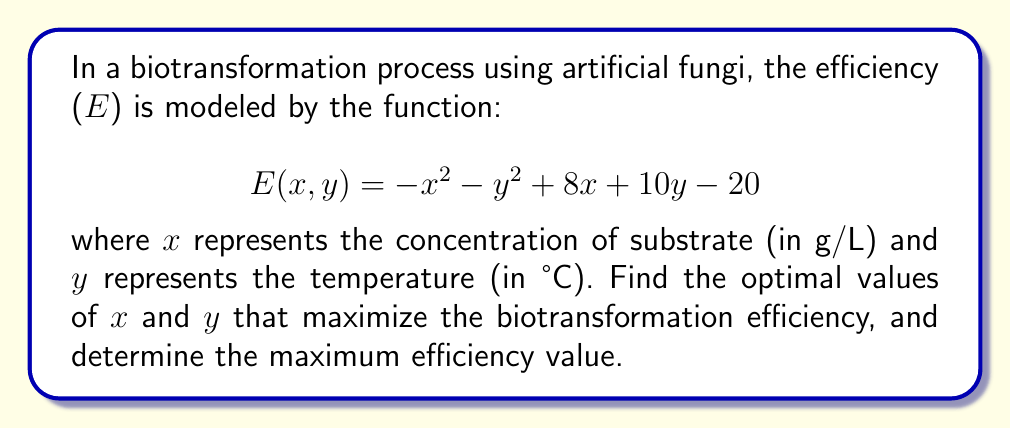Give your solution to this math problem. To find the optimal values of x and y that maximize the biotransformation efficiency, we need to find the critical points of the function E(x, y) and evaluate them.

1. Find the partial derivatives of E with respect to x and y:
   $$\frac{\partial E}{\partial x} = -2x + 8$$
   $$\frac{\partial E}{\partial y} = -2y + 10$$

2. Set both partial derivatives to zero and solve for x and y:
   $$-2x + 8 = 0 \implies x = 4$$
   $$-2y + 10 = 0 \implies y = 5$$

3. The critical point is (4, 5). To confirm this is a maximum, we can check the second partial derivatives:
   $$\frac{\partial^2 E}{\partial x^2} = -2$$
   $$\frac{\partial^2 E}{\partial y^2} = -2$$
   $$\frac{\partial^2 E}{\partial x \partial y} = 0$$

   The Hessian matrix is:
   $$H = \begin{bmatrix} -2 & 0 \\ 0 & -2 \end{bmatrix}$$

   Since the Hessian is negative definite (both eigenvalues are negative), the critical point (4, 5) is indeed a maximum.

4. Calculate the maximum efficiency by plugging the optimal values into the original function:
   $$E(4, 5) = -(4)^2 - (5)^2 + 8(4) + 10(5) - 20$$
   $$= -16 - 25 + 32 + 50 - 20$$
   $$= 21$$

Therefore, the optimal substrate concentration is 4 g/L, the optimal temperature is 5°C, and the maximum biotransformation efficiency is 21.
Answer: Optimal substrate concentration (x): 4 g/L
Optimal temperature (y): 5°C
Maximum biotransformation efficiency: 21 